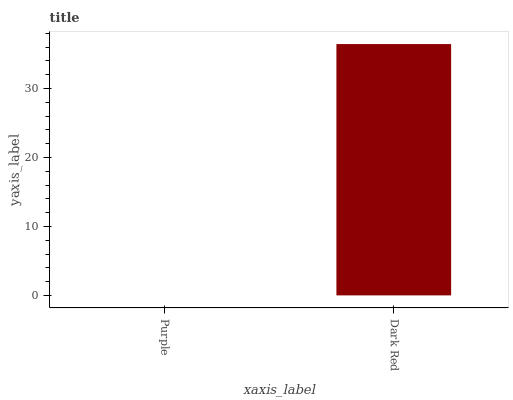Is Purple the minimum?
Answer yes or no. Yes. Is Dark Red the maximum?
Answer yes or no. Yes. Is Dark Red the minimum?
Answer yes or no. No. Is Dark Red greater than Purple?
Answer yes or no. Yes. Is Purple less than Dark Red?
Answer yes or no. Yes. Is Purple greater than Dark Red?
Answer yes or no. No. Is Dark Red less than Purple?
Answer yes or no. No. Is Dark Red the high median?
Answer yes or no. Yes. Is Purple the low median?
Answer yes or no. Yes. Is Purple the high median?
Answer yes or no. No. Is Dark Red the low median?
Answer yes or no. No. 